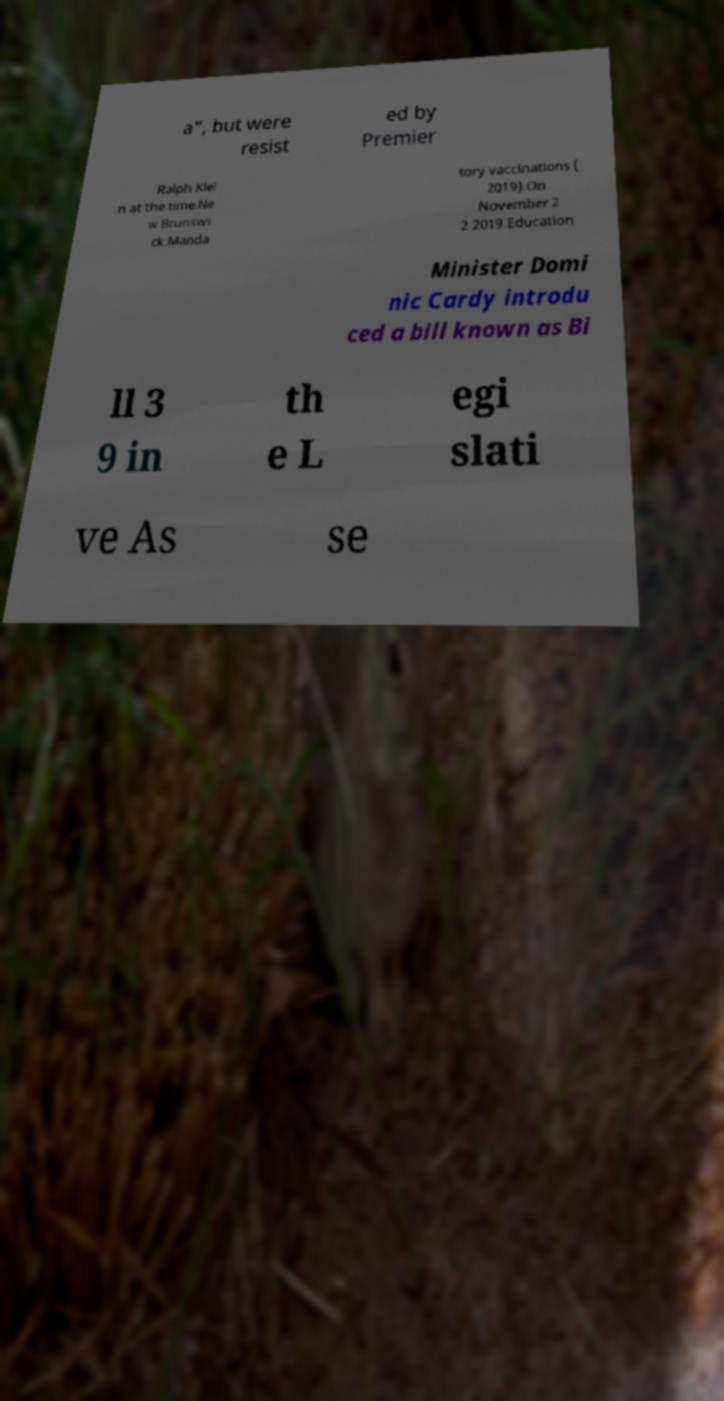Could you extract and type out the text from this image? a", but were resist ed by Premier Ralph Klei n at the time.Ne w Brunswi ck.Manda tory vaccinations ( 2019).On November 2 2 2019 Education Minister Domi nic Cardy introdu ced a bill known as Bi ll 3 9 in th e L egi slati ve As se 